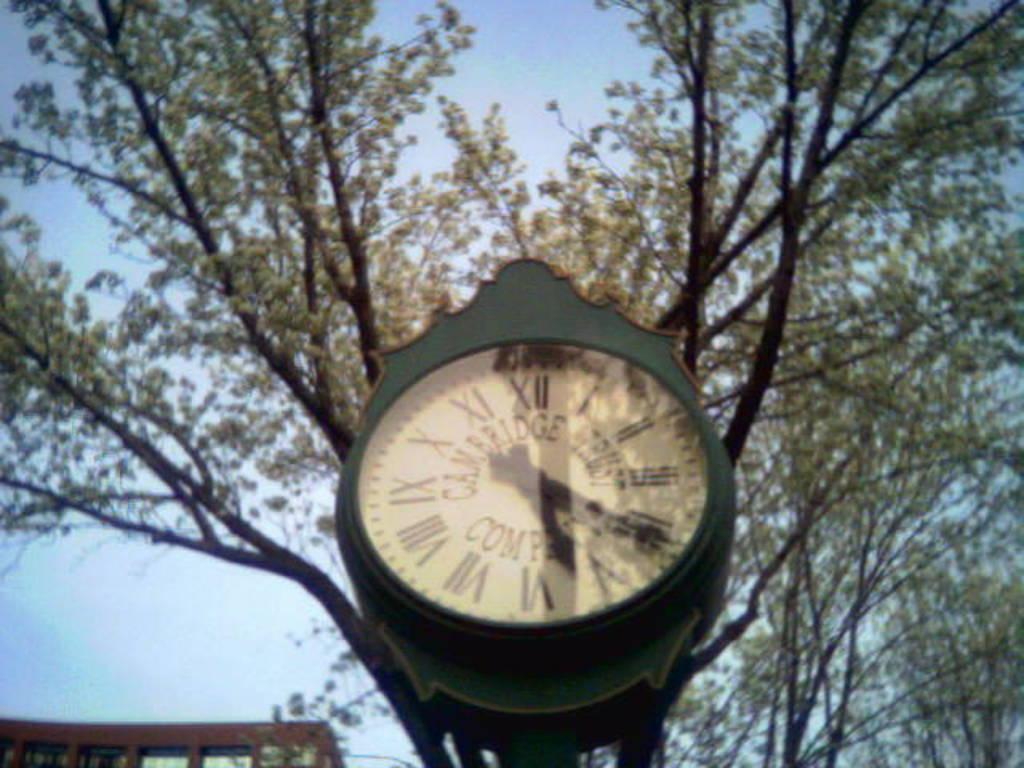Could you give a brief overview of what you see in this image? We can see clock, trees and building. In the background we can see sky. 